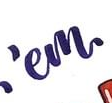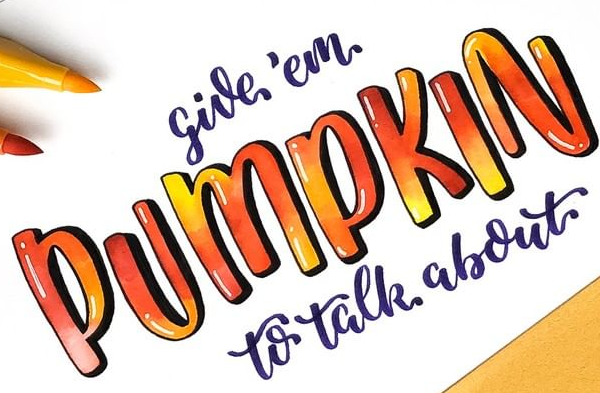What text appears in these images from left to right, separated by a semicolon? 'em; PUMPKIN 